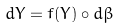<formula> <loc_0><loc_0><loc_500><loc_500>d Y = f ( Y ) \circ d \beta</formula> 